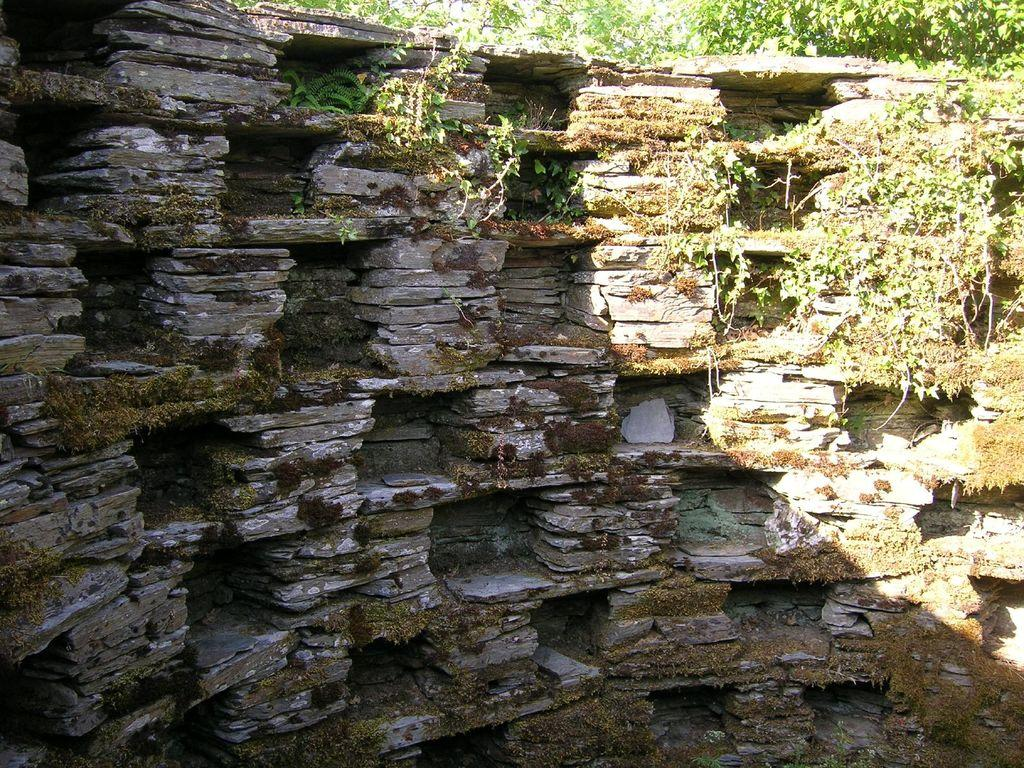What type of wall is shown in the image? There is a wall made up of stones in the image. Are there any plants visible on the wall? Yes, plants are visible at the top of the wall in the image. Can you see a squirrel sneezing while holding a card on the wall in the image? No, there is no squirrel, sneeze, or card present in the image. 